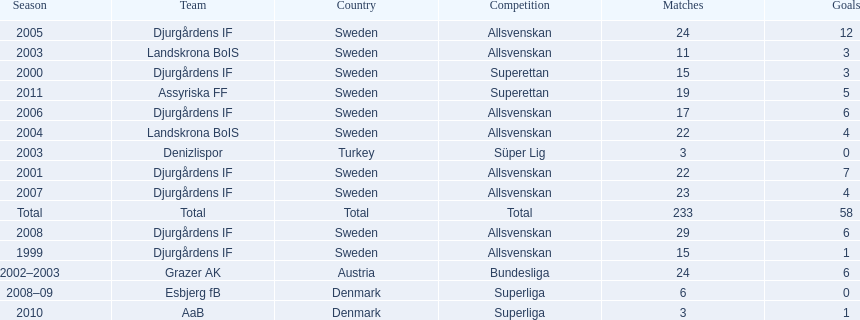How many teams had above 20 matches in the season? 6. 